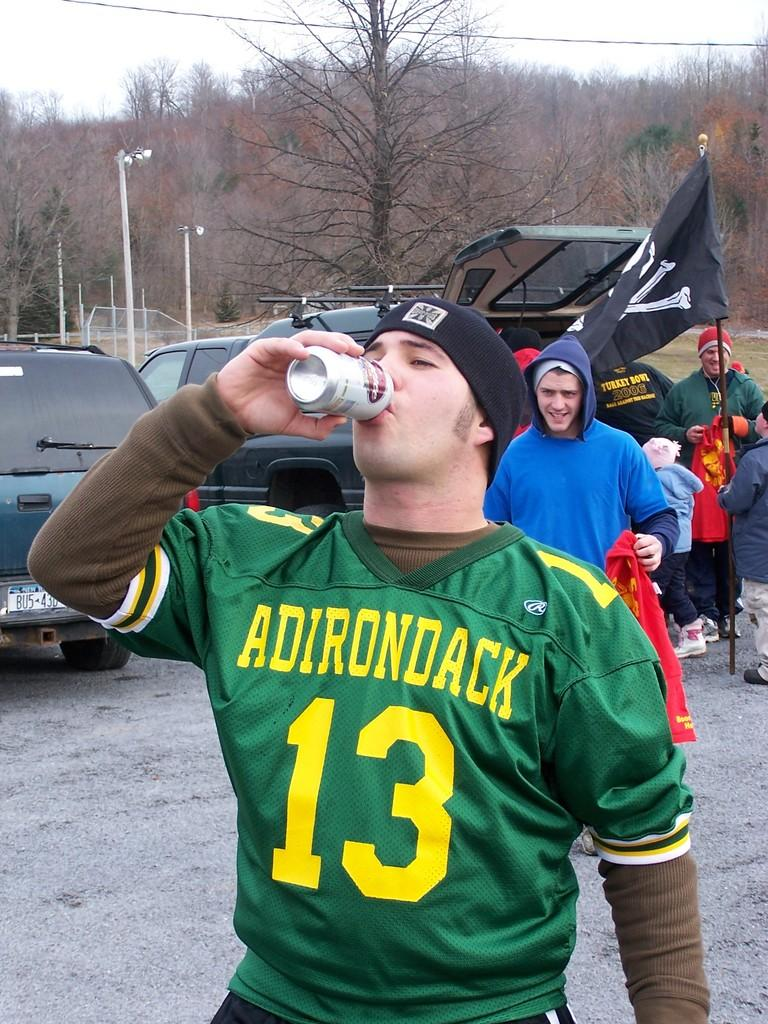<image>
Create a compact narrative representing the image presented. A fan wearing an Adirondack jersey chugs a beer during a football game tailgate. 